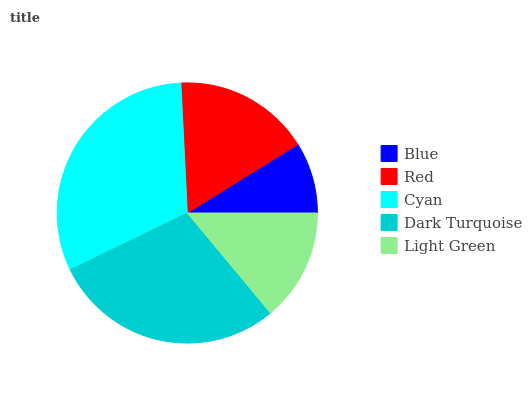Is Blue the minimum?
Answer yes or no. Yes. Is Cyan the maximum?
Answer yes or no. Yes. Is Red the minimum?
Answer yes or no. No. Is Red the maximum?
Answer yes or no. No. Is Red greater than Blue?
Answer yes or no. Yes. Is Blue less than Red?
Answer yes or no. Yes. Is Blue greater than Red?
Answer yes or no. No. Is Red less than Blue?
Answer yes or no. No. Is Red the high median?
Answer yes or no. Yes. Is Red the low median?
Answer yes or no. Yes. Is Blue the high median?
Answer yes or no. No. Is Cyan the low median?
Answer yes or no. No. 